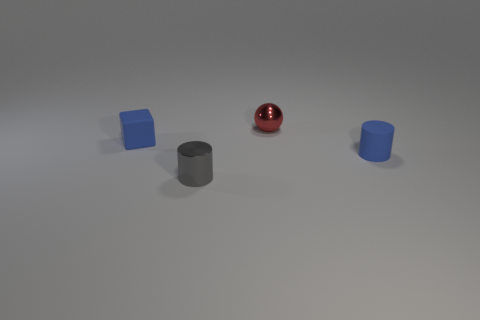There is a small thing that is the same color as the small matte block; what is it made of?
Give a very brief answer. Rubber. There is a shiny thing behind the small object that is in front of the rubber object to the right of the cube; how big is it?
Offer a very short reply. Small. What color is the small object that is both on the right side of the tiny shiny cylinder and in front of the red ball?
Your answer should be very brief. Blue. What number of small blue cylinders are there?
Your answer should be compact. 1. Are there any other things that are the same size as the gray cylinder?
Give a very brief answer. Yes. Does the small blue cube have the same material as the gray cylinder?
Provide a succinct answer. No. There is a blue rubber object behind the blue cylinder; is its size the same as the cylinder behind the metal cylinder?
Offer a terse response. Yes. Is the number of blue cubes less than the number of small yellow metal cylinders?
Keep it short and to the point. No. How many metallic things are either blue cubes or small objects?
Give a very brief answer. 2. Is there a tiny red sphere that is on the right side of the tiny shiny thing to the right of the tiny metal cylinder?
Give a very brief answer. No. 